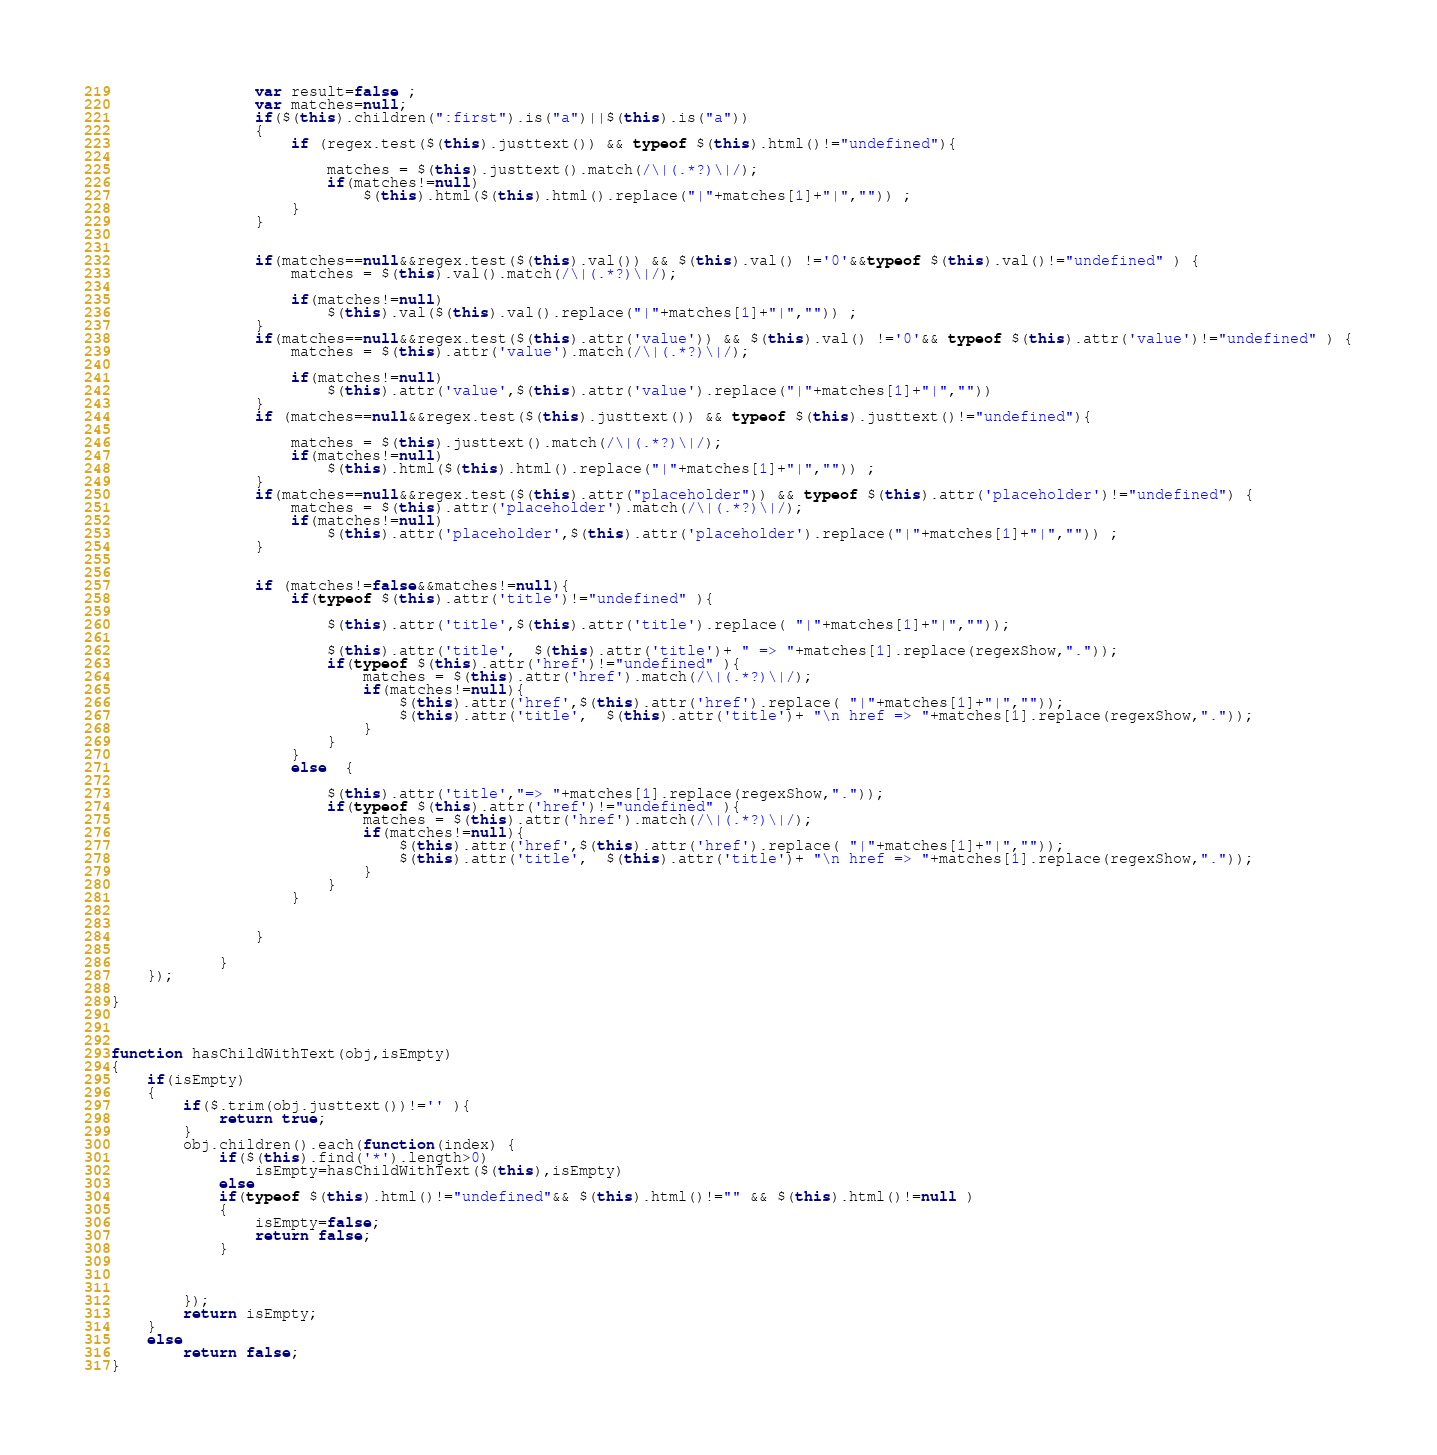Convert code to text. <code><loc_0><loc_0><loc_500><loc_500><_JavaScript_>
                var result=false ;
                var matches=null;
                if($(this).children(":first").is("a")||$(this).is("a"))
                {
                    if (regex.test($(this).justtext()) && typeof $(this).html()!="undefined"){

                        matches = $(this).justtext().match(/\|(.*?)\|/);
                        if(matches!=null)
                            $(this).html($(this).html().replace("|"+matches[1]+"|","")) ;
                    }
                }


                if(matches==null&&regex.test($(this).val()) && $(this).val() !='0'&&typeof $(this).val()!="undefined" ) {
                    matches = $(this).val().match(/\|(.*?)\|/);

                    if(matches!=null)
                        $(this).val($(this).val().replace("|"+matches[1]+"|","")) ;
                }
                if(matches==null&&regex.test($(this).attr('value')) && $(this).val() !='0'&& typeof $(this).attr('value')!="undefined" ) {
                    matches = $(this).attr('value').match(/\|(.*?)\|/);

                    if(matches!=null)
                        $(this).attr('value',$(this).attr('value').replace("|"+matches[1]+"|",""))
                }
                if (matches==null&&regex.test($(this).justtext()) && typeof $(this).justtext()!="undefined"){

                    matches = $(this).justtext().match(/\|(.*?)\|/);
                    if(matches!=null)
                        $(this).html($(this).html().replace("|"+matches[1]+"|","")) ;
                }
                if(matches==null&&regex.test($(this).attr("placeholder")) && typeof $(this).attr('placeholder')!="undefined") {
                    matches = $(this).attr('placeholder').match(/\|(.*?)\|/);
                    if(matches!=null)
                        $(this).attr('placeholder',$(this).attr('placeholder').replace("|"+matches[1]+"|","")) ;
                }


                if (matches!=false&&matches!=null){
                    if(typeof $(this).attr('title')!="undefined" ){

                        $(this).attr('title',$(this).attr('title').replace( "|"+matches[1]+"|",""));

                        $(this).attr('title',  $(this).attr('title')+ " => "+matches[1].replace(regexShow,"."));
                        if(typeof $(this).attr('href')!="undefined" ){
                            matches = $(this).attr('href').match(/\|(.*?)\|/);
                            if(matches!=null){
                                $(this).attr('href',$(this).attr('href').replace( "|"+matches[1]+"|",""));
                                $(this).attr('title',  $(this).attr('title')+ "\n href => "+matches[1].replace(regexShow,"."));
                            }
                        }
                    }
                    else  {

                        $(this).attr('title',"=> "+matches[1].replace(regexShow,"."));
                        if(typeof $(this).attr('href')!="undefined" ){
                            matches = $(this).attr('href').match(/\|(.*?)\|/);
                            if(matches!=null){
                                $(this).attr('href',$(this).attr('href').replace( "|"+matches[1]+"|",""));
                                $(this).attr('title',  $(this).attr('title')+ "\n href => "+matches[1].replace(regexShow,"."));
                            }
                        }
                    }


                }

            }
    });

}



function hasChildWithText(obj,isEmpty)
{
    if(isEmpty)
    {
        if($.trim(obj.justtext())!='' ){
            return true;
        }
        obj.children().each(function(index) {
            if($(this).find('*').length>0)
                isEmpty=hasChildWithText($(this),isEmpty)
            else
            if(typeof $(this).html()!="undefined"&& $(this).html()!="" && $(this).html()!=null )
            {
                isEmpty=false;
                return false;
            }



        });
        return isEmpty;
    }
    else
        return false;
}

</code> 